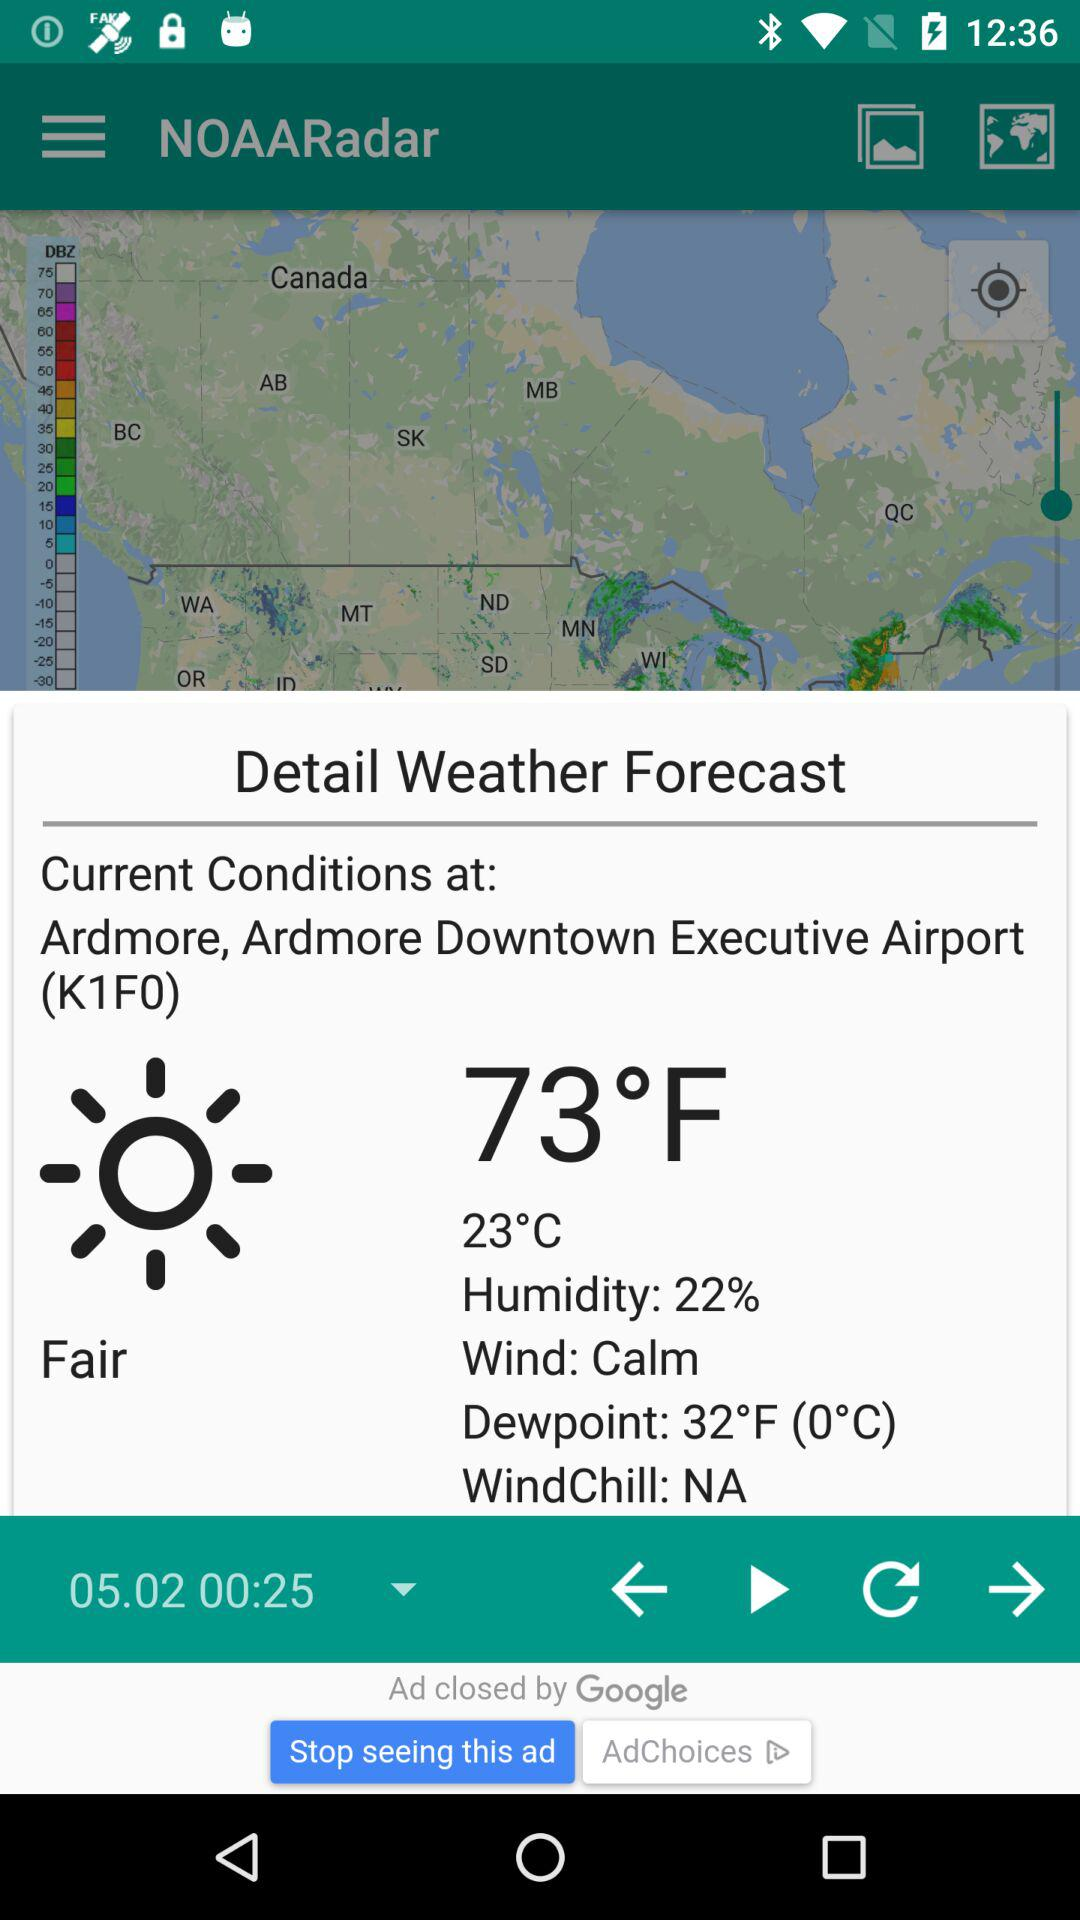What is the unit of temperature? The unit of temperature is °F. 